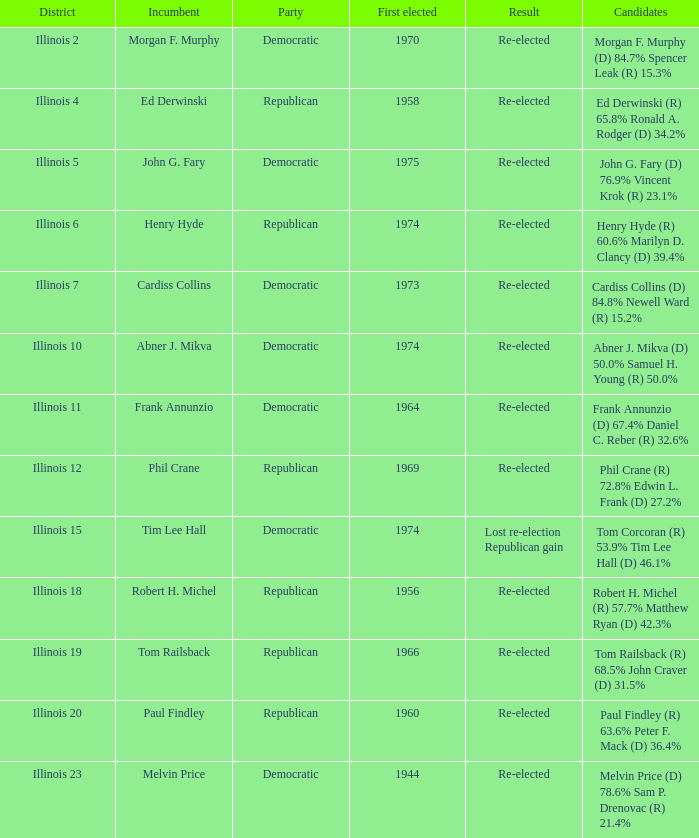Give me the full table as a dictionary. {'header': ['District', 'Incumbent', 'Party', 'First elected', 'Result', 'Candidates'], 'rows': [['Illinois 2', 'Morgan F. Murphy', 'Democratic', '1970', 'Re-elected', 'Morgan F. Murphy (D) 84.7% Spencer Leak (R) 15.3%'], ['Illinois 4', 'Ed Derwinski', 'Republican', '1958', 'Re-elected', 'Ed Derwinski (R) 65.8% Ronald A. Rodger (D) 34.2%'], ['Illinois 5', 'John G. Fary', 'Democratic', '1975', 'Re-elected', 'John G. Fary (D) 76.9% Vincent Krok (R) 23.1%'], ['Illinois 6', 'Henry Hyde', 'Republican', '1974', 'Re-elected', 'Henry Hyde (R) 60.6% Marilyn D. Clancy (D) 39.4%'], ['Illinois 7', 'Cardiss Collins', 'Democratic', '1973', 'Re-elected', 'Cardiss Collins (D) 84.8% Newell Ward (R) 15.2%'], ['Illinois 10', 'Abner J. Mikva', 'Democratic', '1974', 'Re-elected', 'Abner J. Mikva (D) 50.0% Samuel H. Young (R) 50.0%'], ['Illinois 11', 'Frank Annunzio', 'Democratic', '1964', 'Re-elected', 'Frank Annunzio (D) 67.4% Daniel C. Reber (R) 32.6%'], ['Illinois 12', 'Phil Crane', 'Republican', '1969', 'Re-elected', 'Phil Crane (R) 72.8% Edwin L. Frank (D) 27.2%'], ['Illinois 15', 'Tim Lee Hall', 'Democratic', '1974', 'Lost re-election Republican gain', 'Tom Corcoran (R) 53.9% Tim Lee Hall (D) 46.1%'], ['Illinois 18', 'Robert H. Michel', 'Republican', '1956', 'Re-elected', 'Robert H. Michel (R) 57.7% Matthew Ryan (D) 42.3%'], ['Illinois 19', 'Tom Railsback', 'Republican', '1966', 'Re-elected', 'Tom Railsback (R) 68.5% John Craver (D) 31.5%'], ['Illinois 20', 'Paul Findley', 'Republican', '1960', 'Re-elected', 'Paul Findley (R) 63.6% Peter F. Mack (D) 36.4%'], ['Illinois 23', 'Melvin Price', 'Democratic', '1944', 'Re-elected', 'Melvin Price (D) 78.6% Sam P. Drenovac (R) 21.4%']]} Name the party for tim lee hall Democratic. 